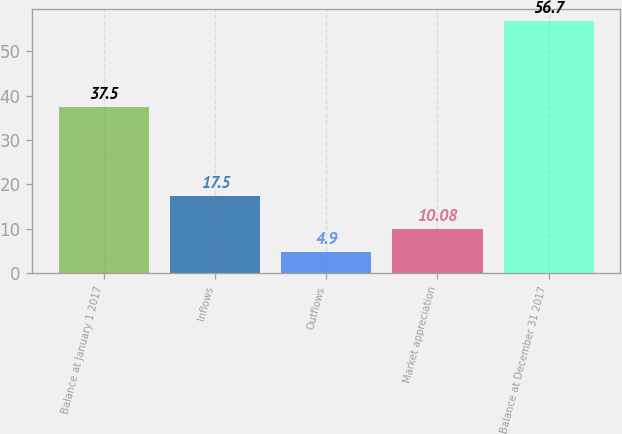Convert chart to OTSL. <chart><loc_0><loc_0><loc_500><loc_500><bar_chart><fcel>Balance at January 1 2017<fcel>Inflows<fcel>Outflows<fcel>Market appreciation<fcel>Balance at December 31 2017<nl><fcel>37.5<fcel>17.5<fcel>4.9<fcel>10.08<fcel>56.7<nl></chart> 